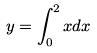Convert formula to latex. <formula><loc_0><loc_0><loc_500><loc_500>y = \int _ { 0 } ^ { 2 } x d x</formula> 